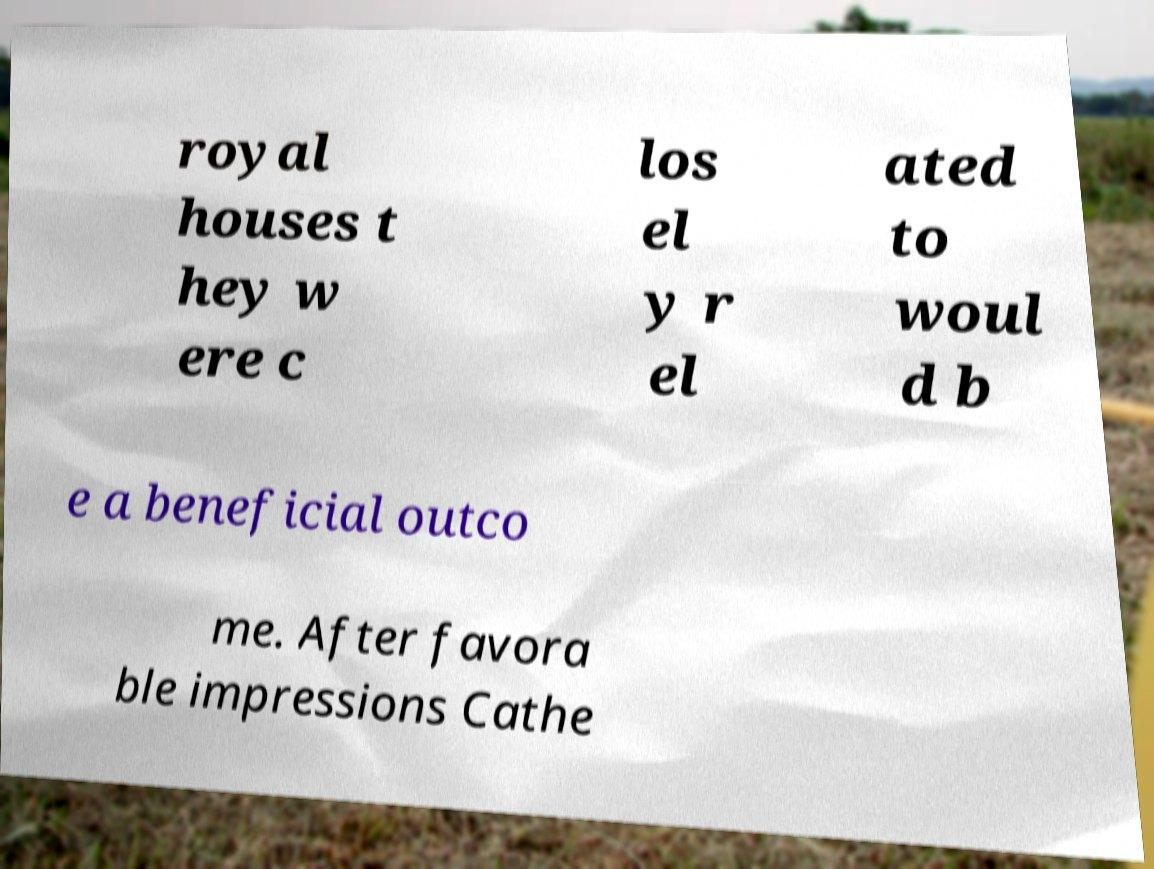Could you extract and type out the text from this image? royal houses t hey w ere c los el y r el ated to woul d b e a beneficial outco me. After favora ble impressions Cathe 